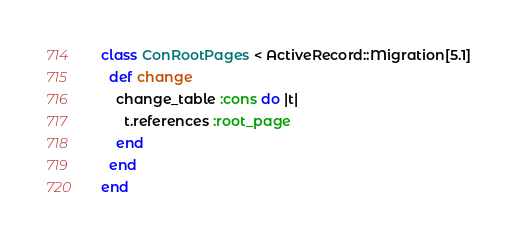Convert code to text. <code><loc_0><loc_0><loc_500><loc_500><_Ruby_>class ConRootPages < ActiveRecord::Migration[5.1]
  def change
    change_table :cons do |t|
      t.references :root_page
    end
  end
end
</code> 